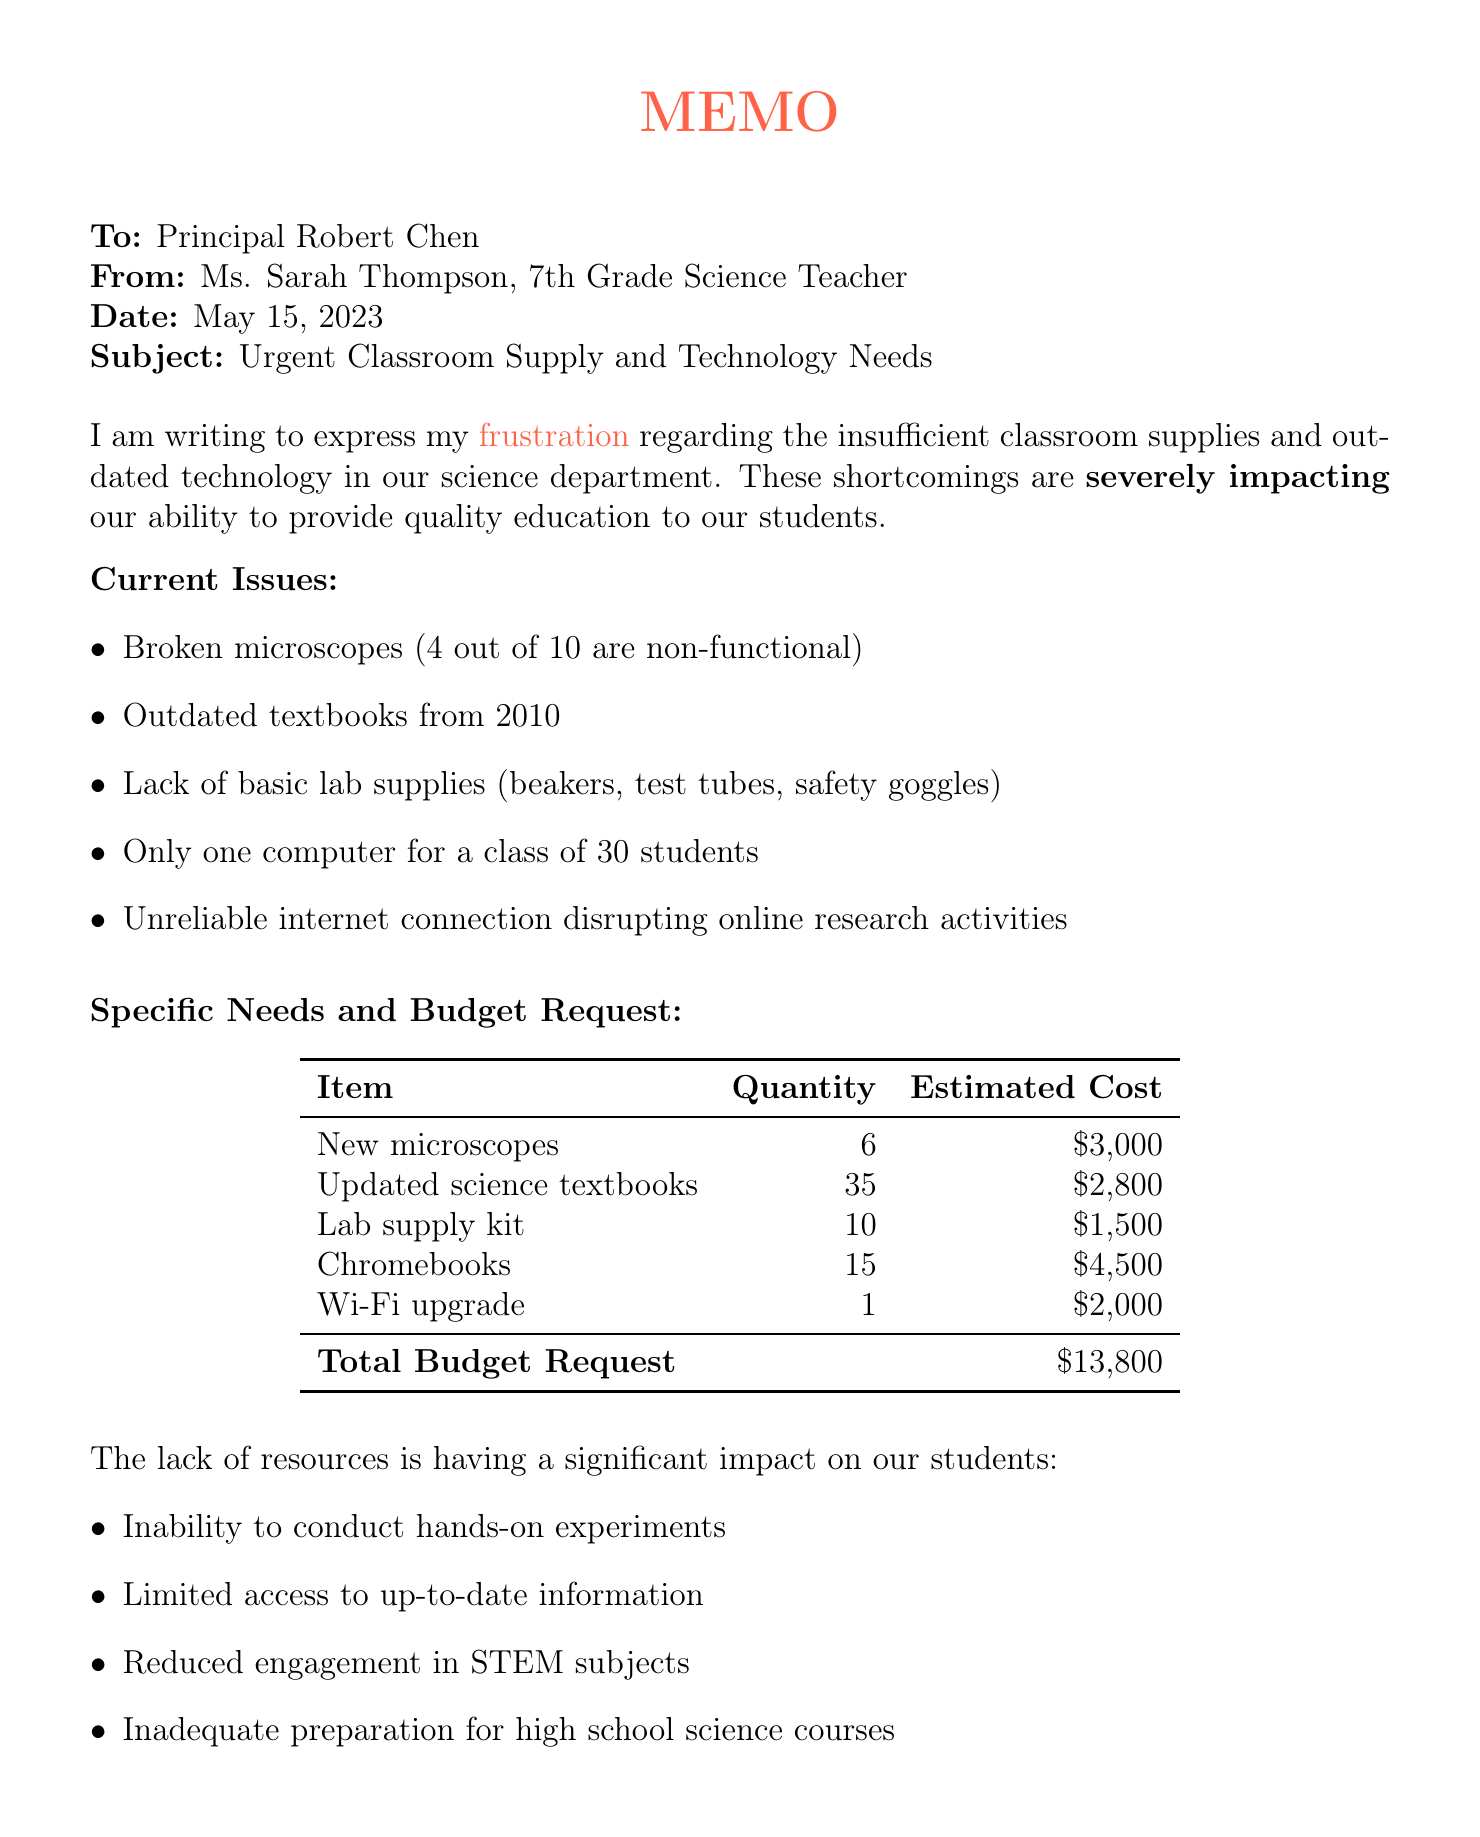What is the sender's name? The sender's name is explicitly mentioned at the beginning of the memo.
Answer: Ms. Sarah Thompson What is the total budget request? The document specifies a total budget request in the table provided.
Answer: $13,800 How many new microscopes are requested? The specific needs section lists the quantity of new microscopes needed.
Answer: 6 What year are the current textbooks from? The document mentions the year of the outdated textbooks directly.
Answer: 2010 What is the position of the sender? The sender's position is clearly stated in the header of the memo.
Answer: 7th Grade Science Teacher What type of upgrade is being requested for internet connectivity? The document specifies the type of upgrade needed in the specific needs section.
Answer: Wi-Fi upgrade Why is the request considered urgent? The urgency is addressed in the conclusion of the memo and relates to upcoming events.
Answer: Science fair and standardized tests Which neighboring school is mentioned as having upgraded facilities? The document mentions a specific neighboring school in comparison to highlight disparities.
Answer: Bronx Science Middle School What are two impacts on students due to insufficient supplies? The document lists various impacts on students and two can be directly identified.
Answer: Inability to conduct hands-on experiments, Limited access to up-to-date information 